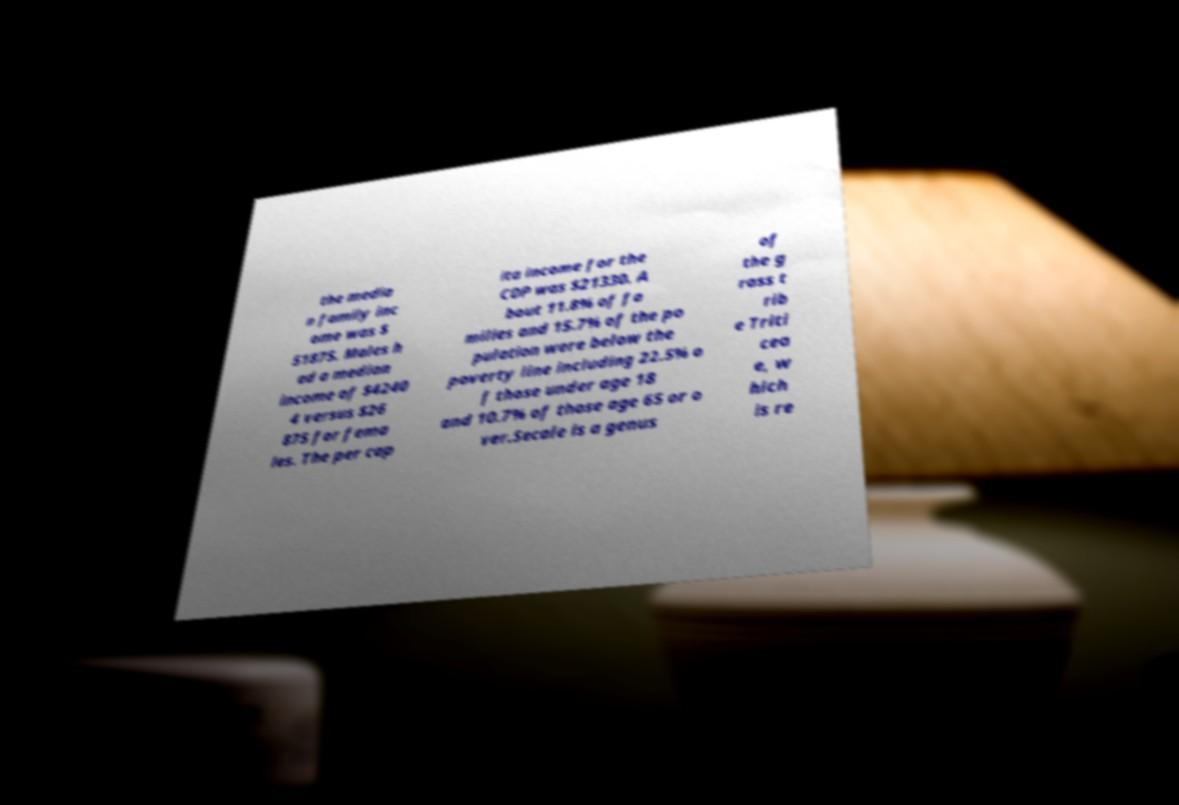What messages or text are displayed in this image? I need them in a readable, typed format. the media n family inc ome was $ 51875. Males h ad a median income of $4240 4 versus $26 875 for fema les. The per cap ita income for the CDP was $21330. A bout 11.8% of fa milies and 15.7% of the po pulation were below the poverty line including 22.5% o f those under age 18 and 10.7% of those age 65 or o ver.Secale is a genus of the g rass t rib e Triti cea e, w hich is re 